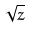<formula> <loc_0><loc_0><loc_500><loc_500>\sqrt { z }</formula> 